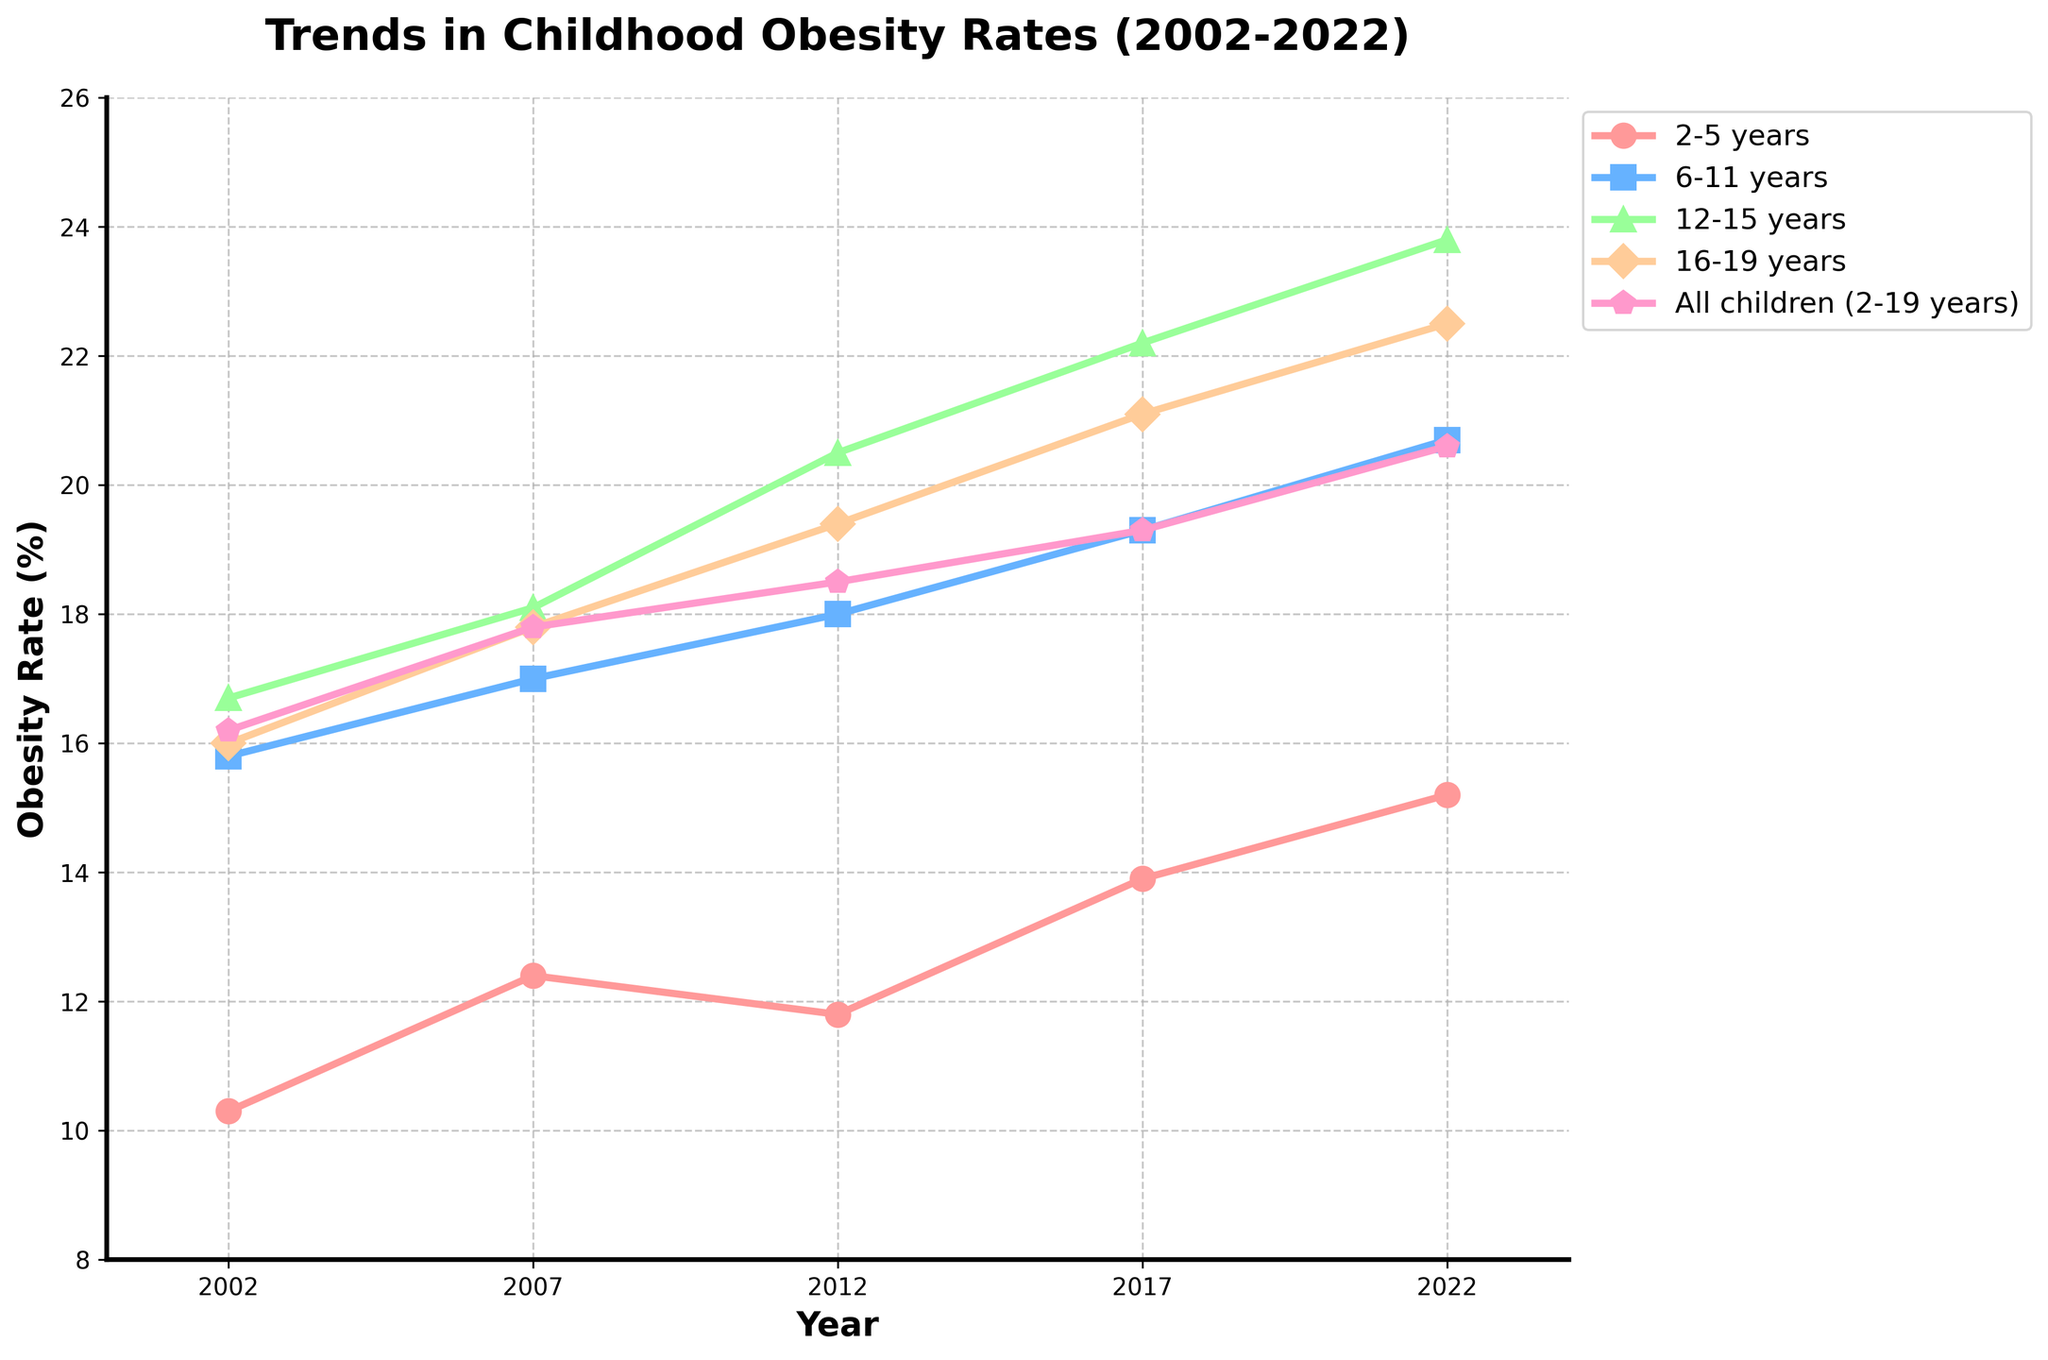What is the trend of obesity rates in the 2-5 years age group over the 20-year period? From the plot, observe the line for the 2-5 years age group and note the changes from 2002 to 2022. The trend shows an increase starting at 10.3% in 2002 and rising steadily to 15.2% in 2022.
Answer: Increasing How do the obesity rates of 12-15 years in 2017 compare to those of 6-11 years in the same year? Locate both age groups on the plot and compare their obesity rates for the year 2017. The obesity rate for the 12-15 years is 22.2%, while for the 6-11 years it is 19.3%.
Answer: 22.2% vs. 19.3% Which age group saw the highest increase in obesity rates between 2002 and 2022? Identify and calculate the difference in obesity rates for each age group between 2002 and 2022. The increases are:
- 2-5 years: 15.2 - 10.3 = 4.9%
- 6-11 years: 20.7 - 15.8 = 4.9%
- 12-15 years: 23.8 - 16.7 = 7.1%
- 16-19 years: 22.5 - 16.0 = 6.5%
The 12-15 years age group saw the highest increase.
Answer: 12-15 years What is the average obesity rate for all children (2-19 years) in the years 2002, 2012, and 2022? Calculate the average using the values for all children in the specified years: (16.2 + 18.5 + 20.6) / 3 = 55.3 / 3
Answer: 18.43% Which age group had the lowest obesity rate in any given year, and what was that rate? Search for the lowest values across all plotted lines. The 2-5 years age group in 2002 had the lowest obesity rate of 10.3%.
Answer: 2-5 years with 10.3% Did the obesity rate for the 6-11 years age group ever decrease over the 20-year period? Check the line for the 6-11 years age group across the years. The line always shows an increasing trend from 2002 to 2022.
Answer: No Compare the obesity rates of the 16-19 years age group in 2002 and 2022. What is the percentage increase? Calculate the percentage increase: ((22.5 - 16.0) / 16.0) * 100% = 40.63%
Answer: 40.63% What trend can be observed in the overall childhood obesity rate across all children (2-19 years) from 2007 to 2022? Look at the line for all children between 2007 and 2022. It shows a continual rise from 17.8% in 2007 to 20.6% in 2022.
Answer: Increasing 